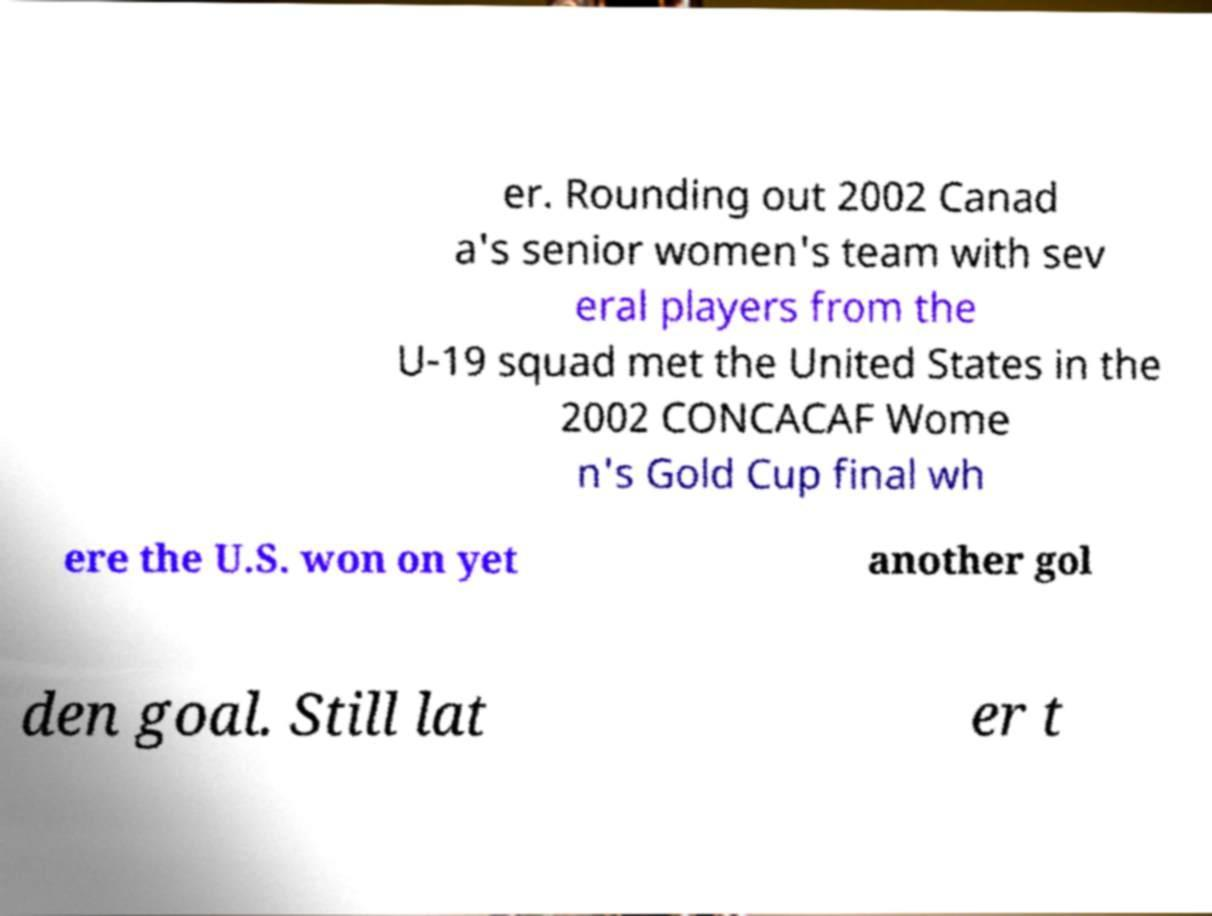Can you accurately transcribe the text from the provided image for me? er. Rounding out 2002 Canad a's senior women's team with sev eral players from the U-19 squad met the United States in the 2002 CONCACAF Wome n's Gold Cup final wh ere the U.S. won on yet another gol den goal. Still lat er t 